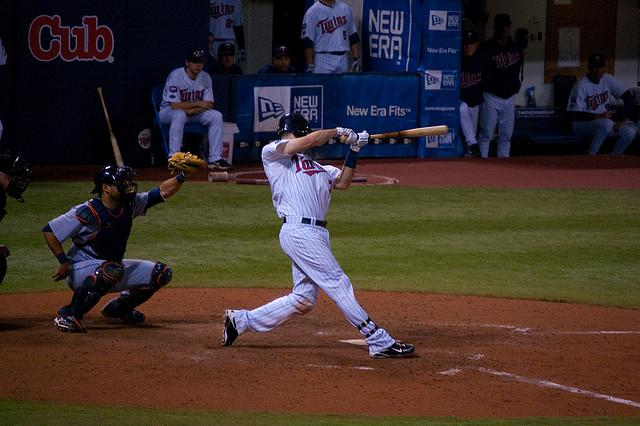What cap/apparel company is a sponsor for the stadium? new era 